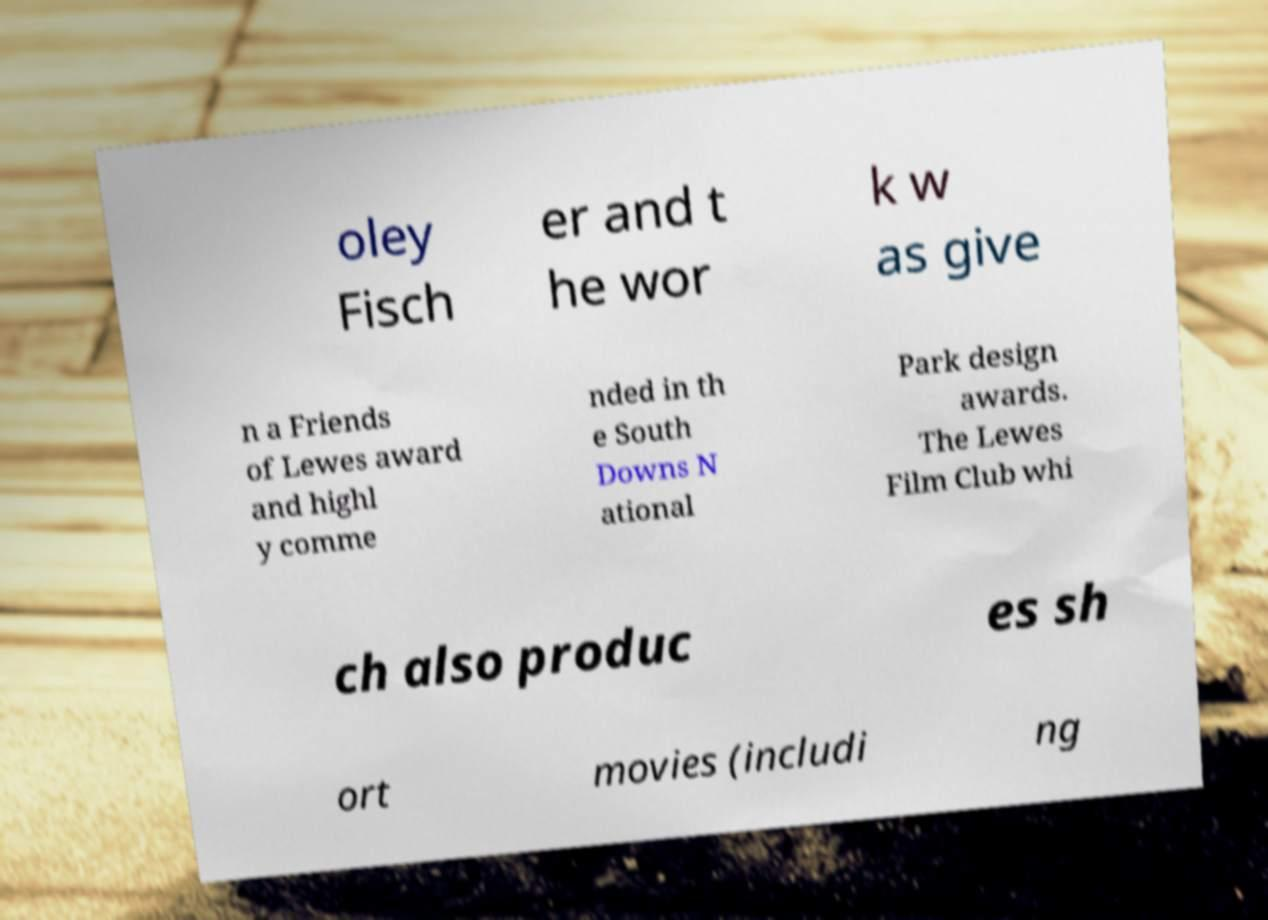There's text embedded in this image that I need extracted. Can you transcribe it verbatim? oley Fisch er and t he wor k w as give n a Friends of Lewes award and highl y comme nded in th e South Downs N ational Park design awards. The Lewes Film Club whi ch also produc es sh ort movies (includi ng 